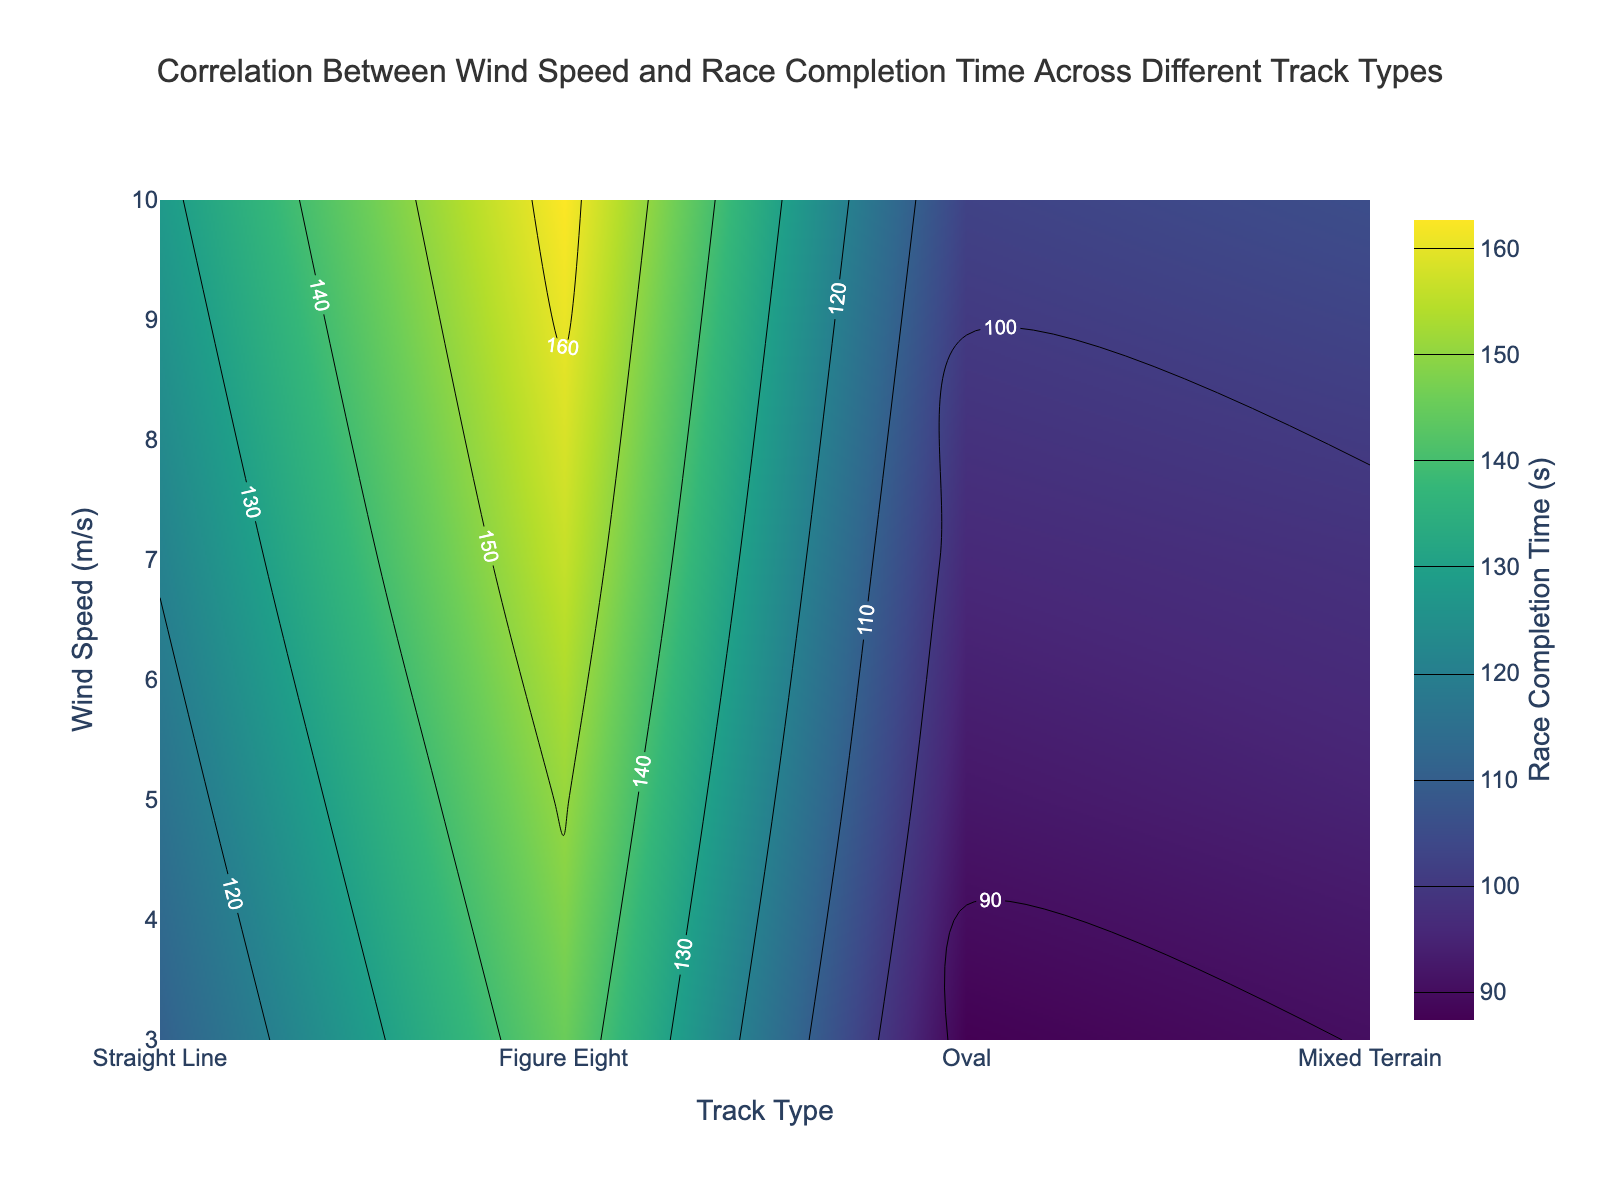What is the title of the plot? The title is usually found at the top center of the plot. In this figure, it summarizes the main information visually presented.
Answer: Correlation Between Wind Speed and Race Completion Time Across Different Track Types What are the x-axis and y-axis representing? The x-axis and y-axis labels provide information about the dimensions of the plot. The x-axis represents different track types and the y-axis represents wind speeds in meters per second.
Answer: Track Type and Wind Speed (m/s) Which track type shows the highest race completion time at a wind speed of 10 m/s? To find the answer, locate 10 m/s on the y-axis and look horizontally across the different track types. Identify the track type with the highest contour value.
Answer: Mixed Terrain How does race completion time change with increasing wind speeds for the 'Oval' track type? To determine this, look at the contour values along the 'Oval' track type column on the x-axis as you move from lower to higher wind speeds on the y-axis. Observe the upward trend of the contours indicating increasing race completion times.
Answer: Increases What track type has the lowest race completion time at 3 m/s wind speed? Check at the wind speed of 3 m/s on the y-axis and look horizontally across the track types. Identify the track type with the lowest contour value.
Answer: Oval What's the difference in race completion time between 'Straight Line' and 'Figure Eight' track types at 5 m/s wind speed? Locate the wind speed of 5 m/s on the y-axis, and then read the contour values of both 'Straight Line' and 'Figure Eight' track types horizontally. Finally, subtract the value of 'Straight Line' from 'Figure Eight'.
Answer: 21.1 seconds At what wind speed does the 'Mixed Terrain' track type have a race completion time greater than 150 seconds? Find the contour levels corresponding to 150 seconds and see at which wind speed the 'Mixed Terrain' intersects this contour line on the y-axis.
Answer: 5 m/s Which track type exhibits the smallest increase in race completion time from 3 m/s to 10 m/s wind speeds? Inspect the contours for each track type from 3 m/s to 10 m/s on the y-axis. Calculate the difference in race completion times between these two points for all track types and identify the smallest difference.
Answer: Oval Is there any track type with a race completion time less than 90 seconds at any wind speed? Look at the contour levels below 90 seconds and see if any track type intersects this range at any given wind speed.
Answer: Yes, Oval at 3 m/s 